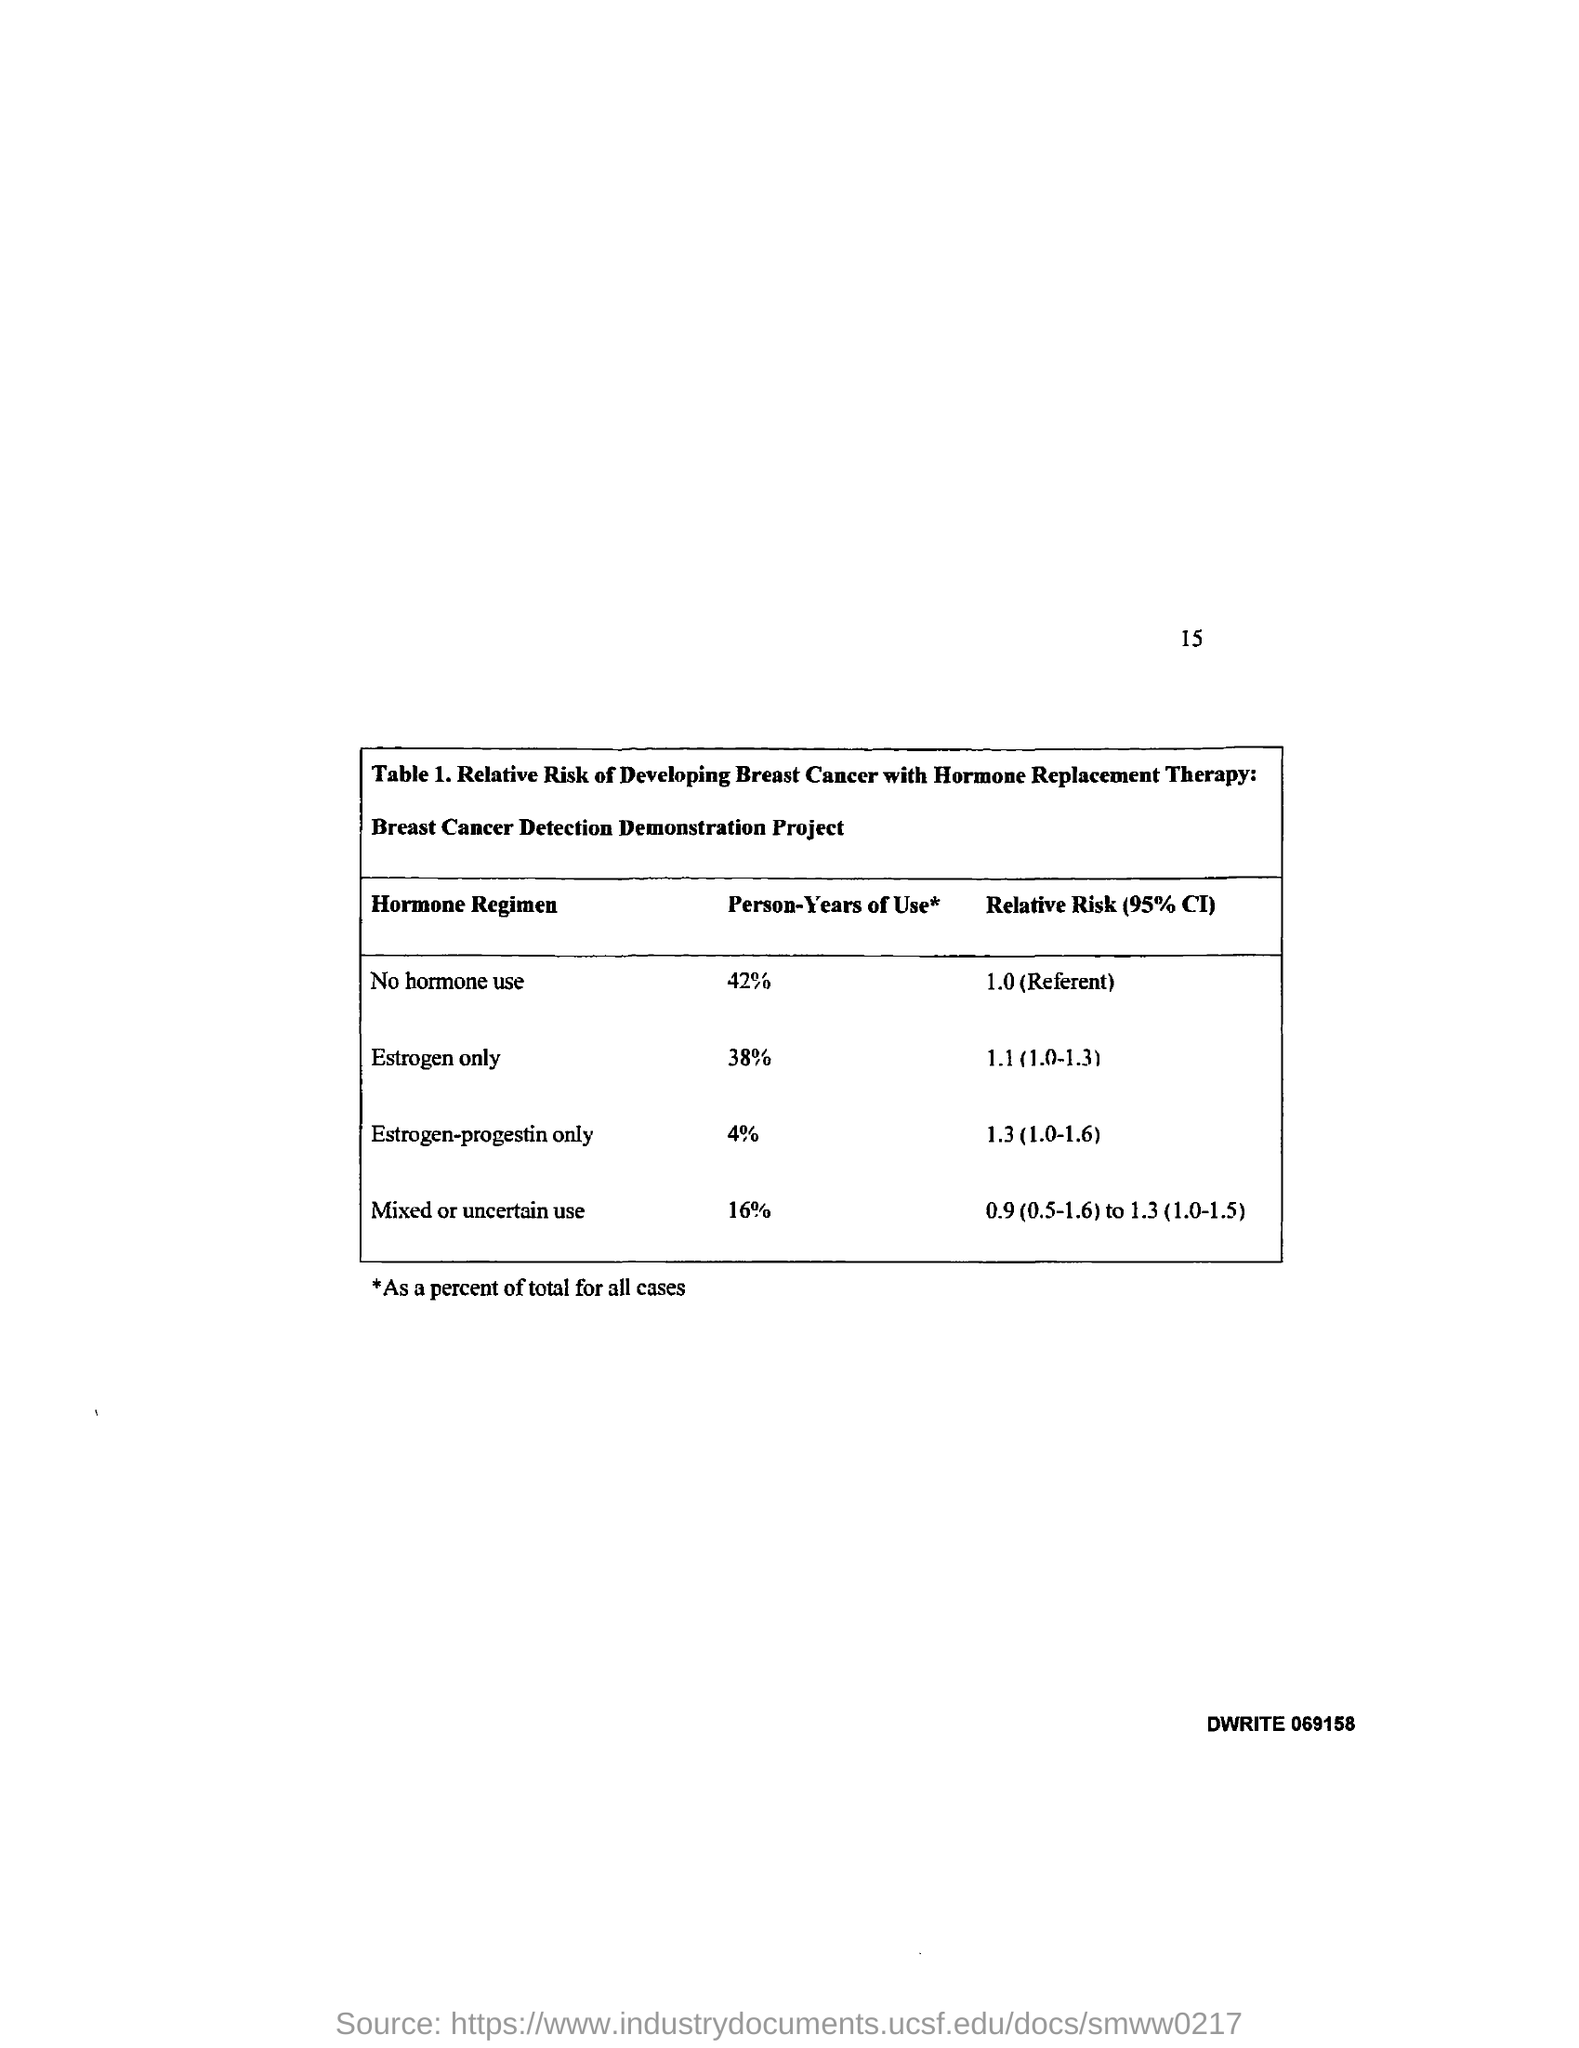What is the Page Number?
Offer a terse response. 15. 